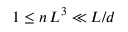<formula> <loc_0><loc_0><loc_500><loc_500>1 \leq n \, L ^ { 3 } \ll L / d</formula> 